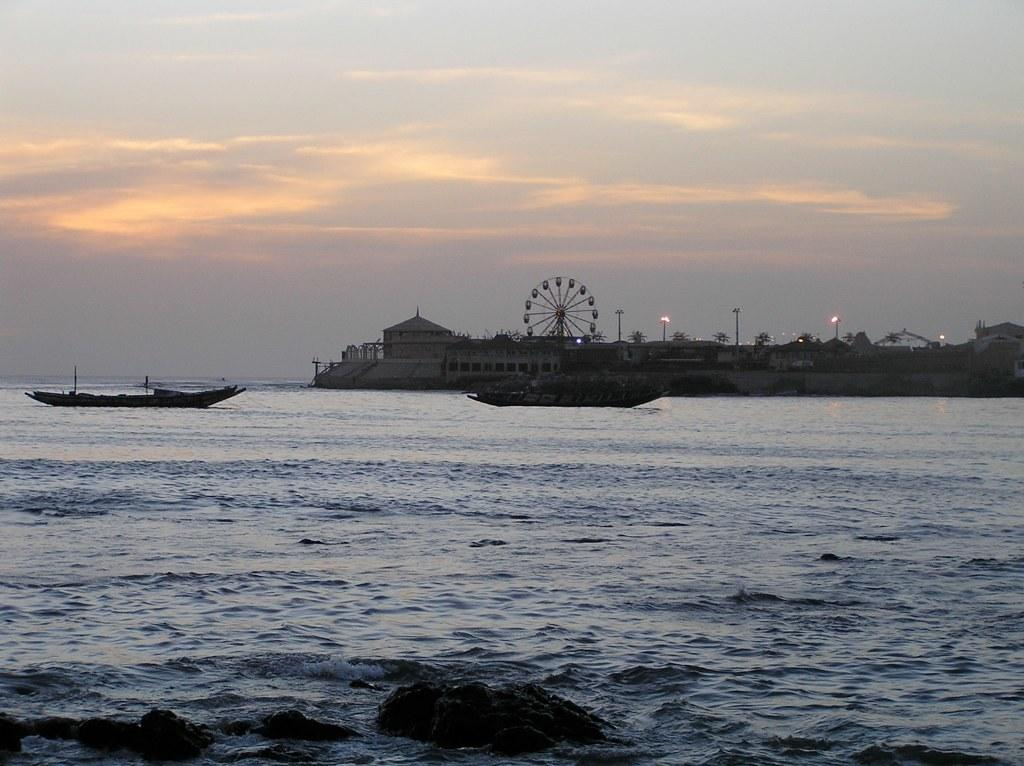What type of vehicles can be seen in the water in the image? There are boats in the water in the image. What structures can be seen in the image? There are buildings visible in the image. What type of natural elements are present in the image? There are trees in the image. What type of lighting is present in the image? There are pole lights in the image. What type of amusement ride can be seen in the image? There is a giant wheel in the image. How would you describe the weather based on the image? The sky is cloudy in the image. What type of obstacles are present in the water? There are rocks in the water in the image. Can you tell me how many angles are visible in the image? There is no mention of angles in the image, so it is not possible to determine how many are visible. Are there any flying creatures in the image? There is no mention of any flying creatures in the image. Is there a brother present in the image? There is no mention of a brother or any people in the image. 